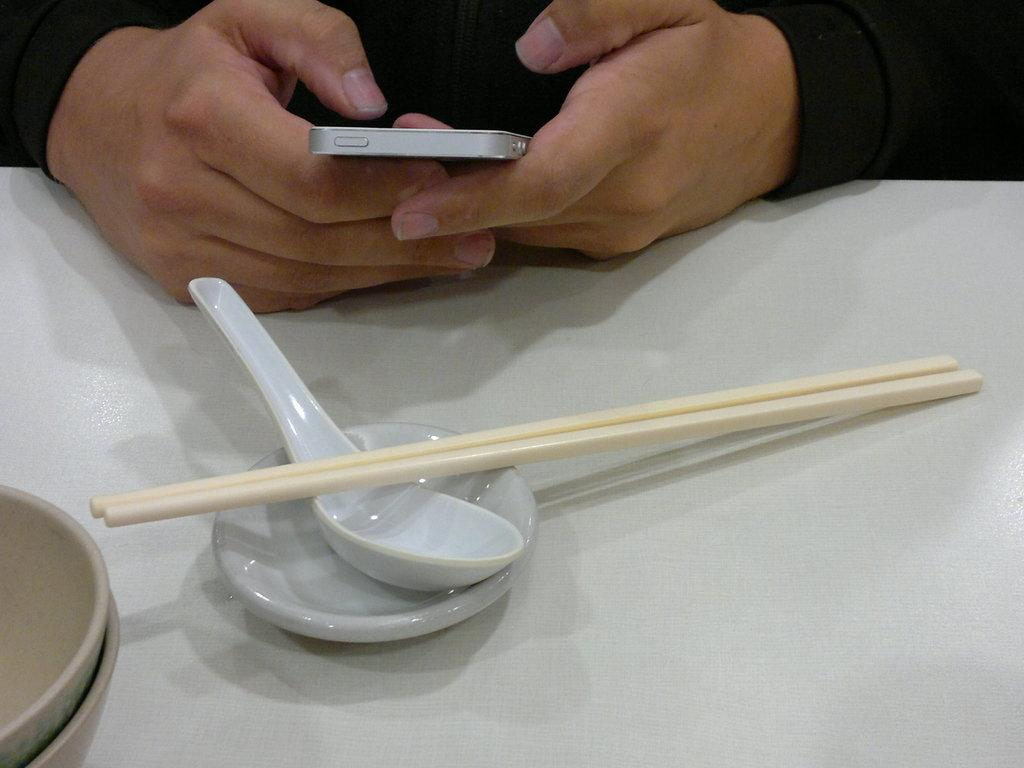Who is the person at the top of the image? There is a person at the top of the image, but their identity is not specified. What is the person wearing in the image? The person is wearing a black shirt in the image. What is the person holding in the image? The person is holding a mobile phone in the image. What is on the table in the image? There is a table in the image with chopsticks, a cup, a spoon, and a bowl on it. What song can be heard playing near the lake in the image? There is no lake or song mentioned in the image; it features a person at the top, wearing a black shirt, holding a mobile phone, and a table with chopsticks, a cup, a spoon, and a bowl on it. 